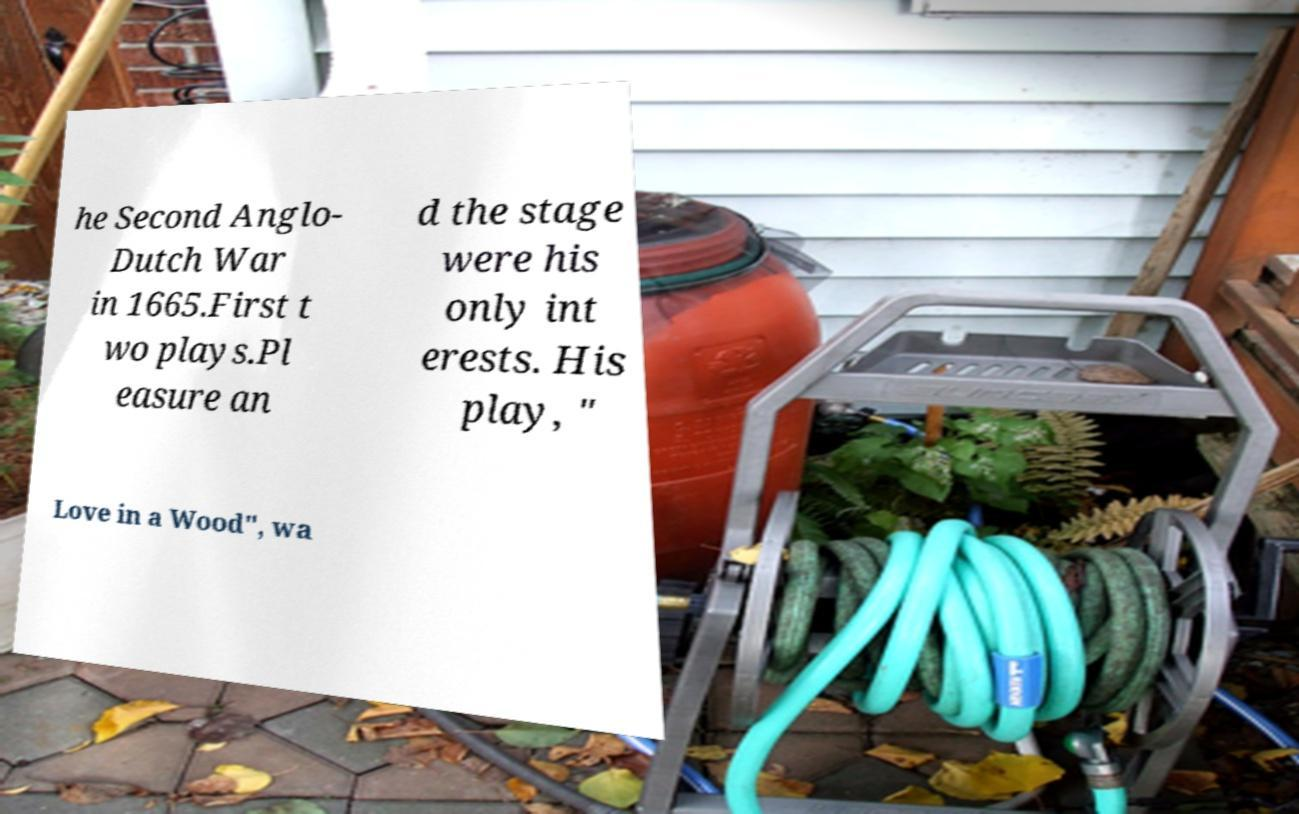Please identify and transcribe the text found in this image. he Second Anglo- Dutch War in 1665.First t wo plays.Pl easure an d the stage were his only int erests. His play, " Love in a Wood", wa 